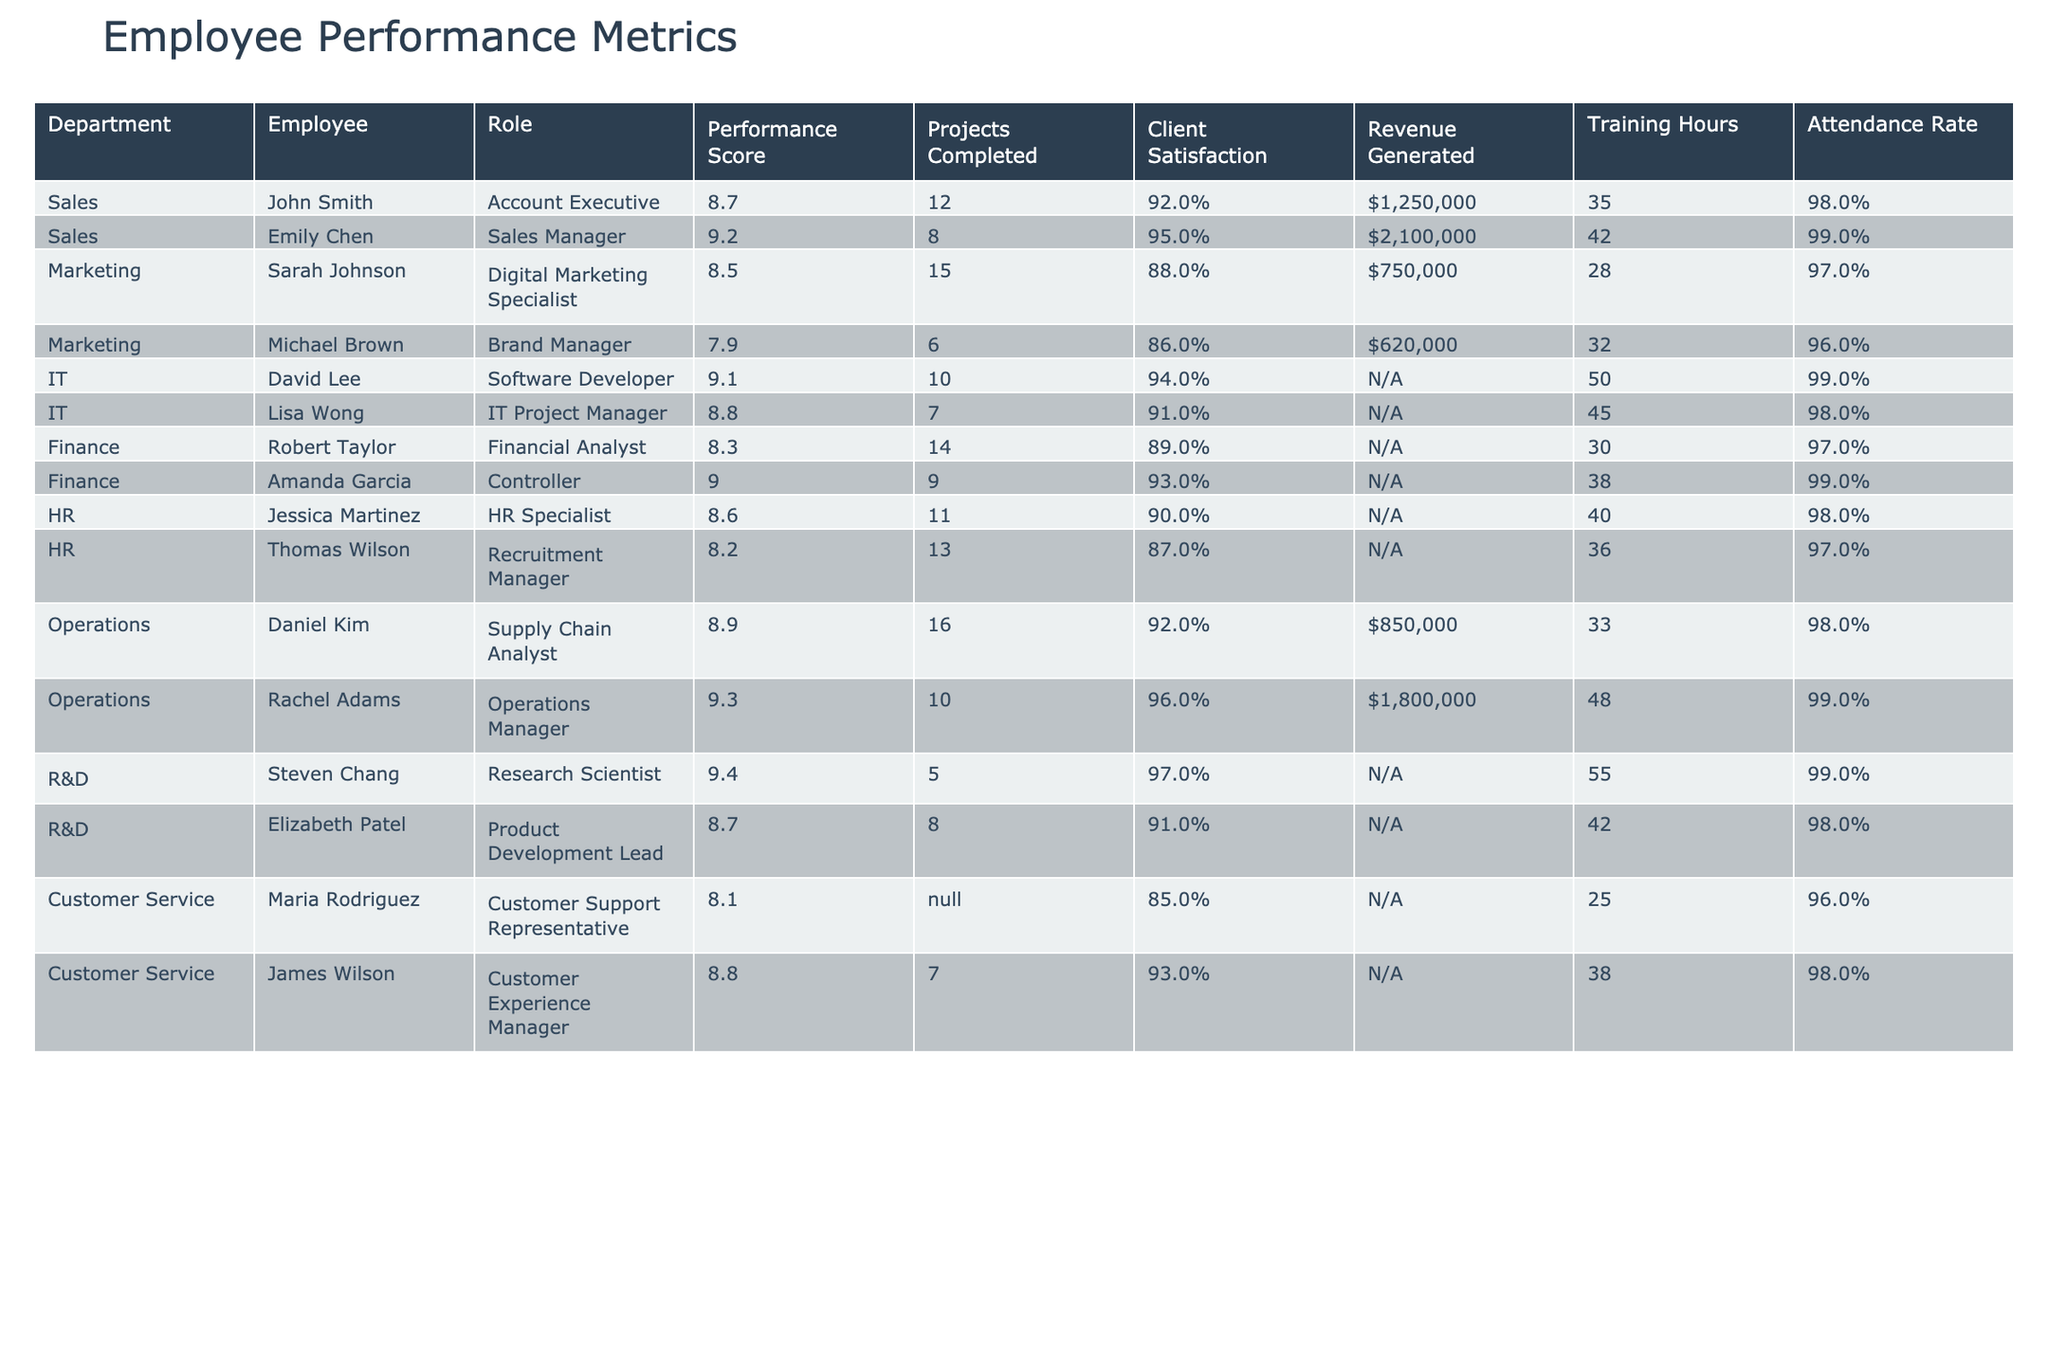What is the highest performance score among all employees? The performance scores are listed in the table, and the highest value is 9.4, which corresponds to Steven Chang in the R&D department.
Answer: 9.4 Which employee completed the most projects? By examining the "Projects Completed" column, Daniel Kim completed the most projects, totaling 16.
Answer: Daniel Kim What is the attendance rate of the Sales department employees? The attendance rates for the Sales department employees are 98% for John Smith and 99% for Emily Chen. To determine the average, we can calculate (98% + 99%) / 2 = 98.5%.
Answer: 98.5% Which department has the highest average client satisfaction? The client satisfaction rates for each department can be averaged as follows: Sales (93.5%), Marketing (87%), IT (92.5%), Finance (91%), HR (88.5%), Operations (94%), R&D (94%), and Customer Service (89%). The highest average is for the Operations department, at 94%.
Answer: Operations Is the revenue generated by Emily Chen greater than that of John Smith? John Smith generated $1,250,000, while Emily Chen generated $2,100,000. Since $2,100,000 is greater than $1,250,000, the answer is yes.
Answer: Yes Which role has the lowest client satisfaction score? The lowest client satisfaction score is from the Brand Manager role, which scored 86%.
Answer: Brand Manager How many training hours did employees in the IT department complete on average? The IT department employees are David Lee with 50 hours and Lisa Wong with 45 hours. The average is (50 + 45) / 2 = 47.5 hours.
Answer: 47.5 Is Jessica Martinez's performance score above the average for the HR department? The two HR employees have scores of 8.6 and 8.2, respectively. The average is (8.6 + 8.2) / 2 = 8.4. Jessica's score of 8.6 is above 8.4, so yes.
Answer: Yes What is the total revenue generated by employees in the Operations department? The total revenue generated is $850,000 from Daniel Kim and $1,800,000 from Rachel Adams. Adding these amounts gives $850,000 + $1,800,000 = $2,650,000.
Answer: $2,650,000 Which department has the employee with the most completed projects, and how many projects did that employee complete? Daniel Kim from the Operations department completed the most projects, which is 16.
Answer: Operations, 16 projects 